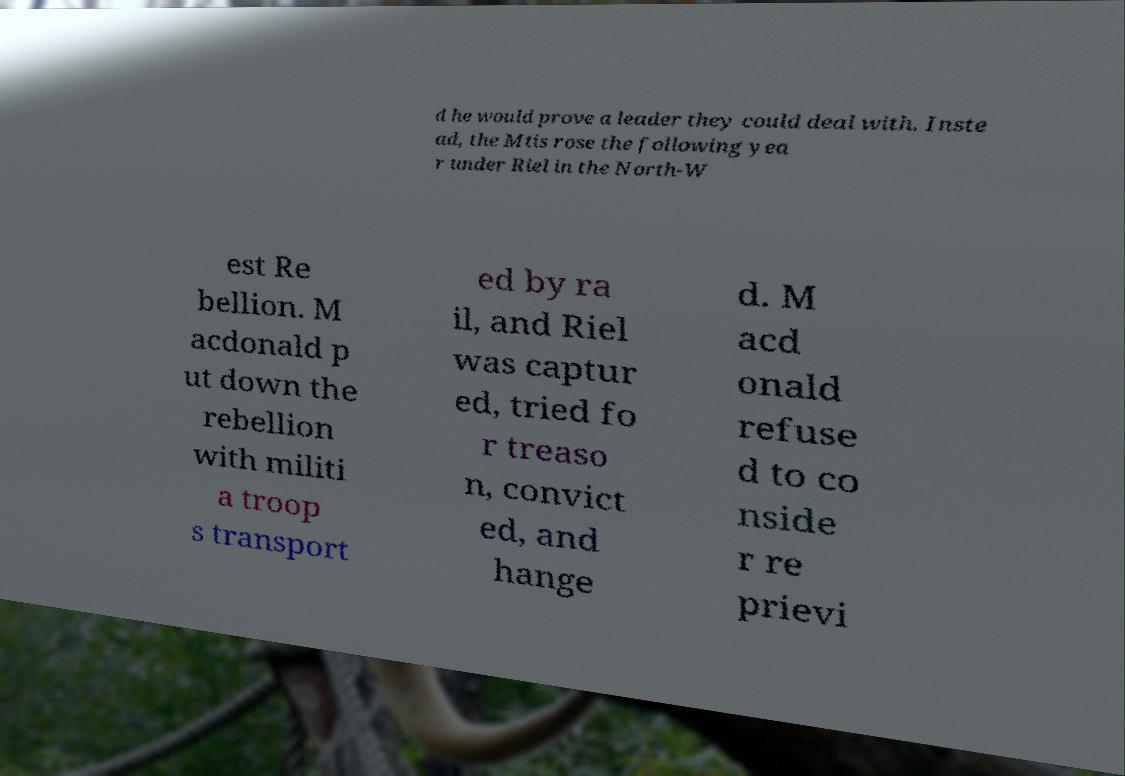Please identify and transcribe the text found in this image. d he would prove a leader they could deal with. Inste ad, the Mtis rose the following yea r under Riel in the North-W est Re bellion. M acdonald p ut down the rebellion with militi a troop s transport ed by ra il, and Riel was captur ed, tried fo r treaso n, convict ed, and hange d. M acd onald refuse d to co nside r re prievi 